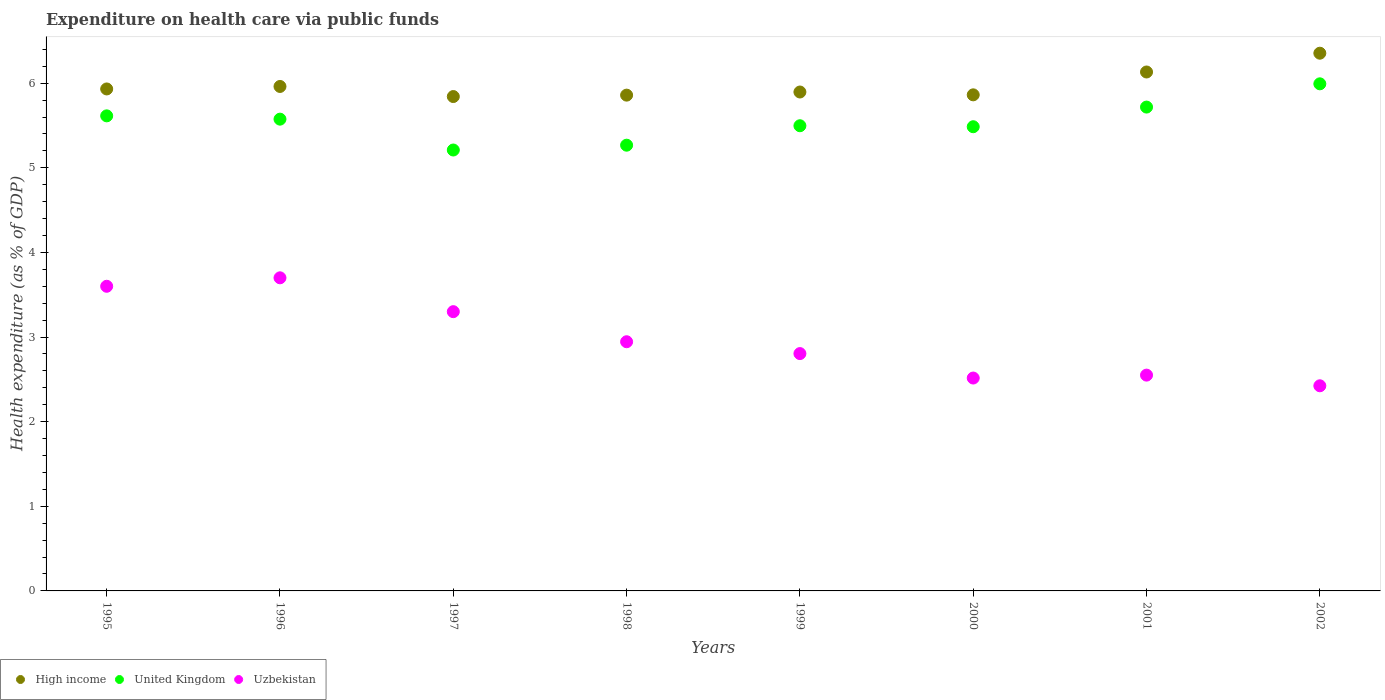Is the number of dotlines equal to the number of legend labels?
Offer a very short reply. Yes. What is the expenditure made on health care in High income in 1999?
Offer a very short reply. 5.9. Across all years, what is the maximum expenditure made on health care in Uzbekistan?
Provide a succinct answer. 3.7. Across all years, what is the minimum expenditure made on health care in Uzbekistan?
Provide a succinct answer. 2.42. What is the total expenditure made on health care in Uzbekistan in the graph?
Your response must be concise. 23.84. What is the difference between the expenditure made on health care in Uzbekistan in 2000 and that in 2001?
Your answer should be compact. -0.03. What is the difference between the expenditure made on health care in United Kingdom in 2002 and the expenditure made on health care in Uzbekistan in 2000?
Ensure brevity in your answer.  3.48. What is the average expenditure made on health care in High income per year?
Keep it short and to the point. 5.98. In the year 2001, what is the difference between the expenditure made on health care in United Kingdom and expenditure made on health care in High income?
Give a very brief answer. -0.41. In how many years, is the expenditure made on health care in United Kingdom greater than 6.2 %?
Offer a very short reply. 0. What is the ratio of the expenditure made on health care in Uzbekistan in 1998 to that in 2002?
Your answer should be compact. 1.21. Is the expenditure made on health care in United Kingdom in 2000 less than that in 2002?
Your answer should be very brief. Yes. What is the difference between the highest and the second highest expenditure made on health care in Uzbekistan?
Give a very brief answer. 0.1. What is the difference between the highest and the lowest expenditure made on health care in Uzbekistan?
Provide a short and direct response. 1.28. Is the sum of the expenditure made on health care in United Kingdom in 1998 and 2001 greater than the maximum expenditure made on health care in High income across all years?
Provide a succinct answer. Yes. What is the difference between two consecutive major ticks on the Y-axis?
Offer a very short reply. 1. Are the values on the major ticks of Y-axis written in scientific E-notation?
Ensure brevity in your answer.  No. Does the graph contain grids?
Offer a very short reply. No. How are the legend labels stacked?
Keep it short and to the point. Horizontal. What is the title of the graph?
Keep it short and to the point. Expenditure on health care via public funds. What is the label or title of the Y-axis?
Offer a terse response. Health expenditure (as % of GDP). What is the Health expenditure (as % of GDP) in High income in 1995?
Your answer should be compact. 5.93. What is the Health expenditure (as % of GDP) of United Kingdom in 1995?
Provide a succinct answer. 5.61. What is the Health expenditure (as % of GDP) of Uzbekistan in 1995?
Give a very brief answer. 3.6. What is the Health expenditure (as % of GDP) of High income in 1996?
Give a very brief answer. 5.96. What is the Health expenditure (as % of GDP) in United Kingdom in 1996?
Your response must be concise. 5.57. What is the Health expenditure (as % of GDP) in Uzbekistan in 1996?
Give a very brief answer. 3.7. What is the Health expenditure (as % of GDP) of High income in 1997?
Offer a very short reply. 5.84. What is the Health expenditure (as % of GDP) of United Kingdom in 1997?
Give a very brief answer. 5.21. What is the Health expenditure (as % of GDP) of Uzbekistan in 1997?
Your response must be concise. 3.3. What is the Health expenditure (as % of GDP) of High income in 1998?
Make the answer very short. 5.86. What is the Health expenditure (as % of GDP) in United Kingdom in 1998?
Ensure brevity in your answer.  5.27. What is the Health expenditure (as % of GDP) in Uzbekistan in 1998?
Your response must be concise. 2.94. What is the Health expenditure (as % of GDP) of High income in 1999?
Your answer should be very brief. 5.9. What is the Health expenditure (as % of GDP) of United Kingdom in 1999?
Your answer should be compact. 5.5. What is the Health expenditure (as % of GDP) in Uzbekistan in 1999?
Offer a very short reply. 2.8. What is the Health expenditure (as % of GDP) of High income in 2000?
Your answer should be compact. 5.86. What is the Health expenditure (as % of GDP) in United Kingdom in 2000?
Offer a very short reply. 5.49. What is the Health expenditure (as % of GDP) of Uzbekistan in 2000?
Keep it short and to the point. 2.52. What is the Health expenditure (as % of GDP) in High income in 2001?
Your response must be concise. 6.13. What is the Health expenditure (as % of GDP) of United Kingdom in 2001?
Give a very brief answer. 5.72. What is the Health expenditure (as % of GDP) of Uzbekistan in 2001?
Make the answer very short. 2.55. What is the Health expenditure (as % of GDP) of High income in 2002?
Offer a terse response. 6.35. What is the Health expenditure (as % of GDP) of United Kingdom in 2002?
Offer a very short reply. 5.99. What is the Health expenditure (as % of GDP) of Uzbekistan in 2002?
Your answer should be compact. 2.42. Across all years, what is the maximum Health expenditure (as % of GDP) of High income?
Offer a very short reply. 6.35. Across all years, what is the maximum Health expenditure (as % of GDP) in United Kingdom?
Your answer should be very brief. 5.99. Across all years, what is the maximum Health expenditure (as % of GDP) in Uzbekistan?
Your answer should be very brief. 3.7. Across all years, what is the minimum Health expenditure (as % of GDP) in High income?
Give a very brief answer. 5.84. Across all years, what is the minimum Health expenditure (as % of GDP) in United Kingdom?
Your answer should be compact. 5.21. Across all years, what is the minimum Health expenditure (as % of GDP) in Uzbekistan?
Ensure brevity in your answer.  2.42. What is the total Health expenditure (as % of GDP) in High income in the graph?
Ensure brevity in your answer.  47.84. What is the total Health expenditure (as % of GDP) of United Kingdom in the graph?
Your answer should be compact. 44.36. What is the total Health expenditure (as % of GDP) of Uzbekistan in the graph?
Your answer should be very brief. 23.84. What is the difference between the Health expenditure (as % of GDP) of High income in 1995 and that in 1996?
Your answer should be very brief. -0.03. What is the difference between the Health expenditure (as % of GDP) of United Kingdom in 1995 and that in 1996?
Give a very brief answer. 0.04. What is the difference between the Health expenditure (as % of GDP) of Uzbekistan in 1995 and that in 1996?
Provide a short and direct response. -0.1. What is the difference between the Health expenditure (as % of GDP) in High income in 1995 and that in 1997?
Ensure brevity in your answer.  0.09. What is the difference between the Health expenditure (as % of GDP) of United Kingdom in 1995 and that in 1997?
Provide a succinct answer. 0.4. What is the difference between the Health expenditure (as % of GDP) of High income in 1995 and that in 1998?
Provide a short and direct response. 0.07. What is the difference between the Health expenditure (as % of GDP) in United Kingdom in 1995 and that in 1998?
Keep it short and to the point. 0.35. What is the difference between the Health expenditure (as % of GDP) in Uzbekistan in 1995 and that in 1998?
Keep it short and to the point. 0.66. What is the difference between the Health expenditure (as % of GDP) in High income in 1995 and that in 1999?
Offer a very short reply. 0.04. What is the difference between the Health expenditure (as % of GDP) of United Kingdom in 1995 and that in 1999?
Your response must be concise. 0.12. What is the difference between the Health expenditure (as % of GDP) of Uzbekistan in 1995 and that in 1999?
Give a very brief answer. 0.8. What is the difference between the Health expenditure (as % of GDP) in High income in 1995 and that in 2000?
Offer a very short reply. 0.07. What is the difference between the Health expenditure (as % of GDP) of United Kingdom in 1995 and that in 2000?
Your answer should be compact. 0.13. What is the difference between the Health expenditure (as % of GDP) of Uzbekistan in 1995 and that in 2000?
Give a very brief answer. 1.08. What is the difference between the Health expenditure (as % of GDP) in High income in 1995 and that in 2001?
Offer a terse response. -0.2. What is the difference between the Health expenditure (as % of GDP) of United Kingdom in 1995 and that in 2001?
Your answer should be very brief. -0.1. What is the difference between the Health expenditure (as % of GDP) in Uzbekistan in 1995 and that in 2001?
Provide a short and direct response. 1.05. What is the difference between the Health expenditure (as % of GDP) in High income in 1995 and that in 2002?
Your response must be concise. -0.42. What is the difference between the Health expenditure (as % of GDP) of United Kingdom in 1995 and that in 2002?
Your response must be concise. -0.38. What is the difference between the Health expenditure (as % of GDP) in Uzbekistan in 1995 and that in 2002?
Your answer should be compact. 1.18. What is the difference between the Health expenditure (as % of GDP) in High income in 1996 and that in 1997?
Your answer should be very brief. 0.12. What is the difference between the Health expenditure (as % of GDP) of United Kingdom in 1996 and that in 1997?
Offer a terse response. 0.36. What is the difference between the Health expenditure (as % of GDP) of Uzbekistan in 1996 and that in 1997?
Keep it short and to the point. 0.4. What is the difference between the Health expenditure (as % of GDP) in High income in 1996 and that in 1998?
Your answer should be very brief. 0.1. What is the difference between the Health expenditure (as % of GDP) in United Kingdom in 1996 and that in 1998?
Your answer should be compact. 0.31. What is the difference between the Health expenditure (as % of GDP) in Uzbekistan in 1996 and that in 1998?
Offer a terse response. 0.76. What is the difference between the Health expenditure (as % of GDP) of High income in 1996 and that in 1999?
Provide a short and direct response. 0.07. What is the difference between the Health expenditure (as % of GDP) in United Kingdom in 1996 and that in 1999?
Your answer should be very brief. 0.08. What is the difference between the Health expenditure (as % of GDP) of Uzbekistan in 1996 and that in 1999?
Make the answer very short. 0.9. What is the difference between the Health expenditure (as % of GDP) in High income in 1996 and that in 2000?
Give a very brief answer. 0.1. What is the difference between the Health expenditure (as % of GDP) in United Kingdom in 1996 and that in 2000?
Your response must be concise. 0.09. What is the difference between the Health expenditure (as % of GDP) in Uzbekistan in 1996 and that in 2000?
Your answer should be compact. 1.18. What is the difference between the Health expenditure (as % of GDP) in High income in 1996 and that in 2001?
Ensure brevity in your answer.  -0.17. What is the difference between the Health expenditure (as % of GDP) of United Kingdom in 1996 and that in 2001?
Your answer should be compact. -0.14. What is the difference between the Health expenditure (as % of GDP) in Uzbekistan in 1996 and that in 2001?
Offer a terse response. 1.15. What is the difference between the Health expenditure (as % of GDP) in High income in 1996 and that in 2002?
Offer a terse response. -0.39. What is the difference between the Health expenditure (as % of GDP) in United Kingdom in 1996 and that in 2002?
Ensure brevity in your answer.  -0.42. What is the difference between the Health expenditure (as % of GDP) of Uzbekistan in 1996 and that in 2002?
Provide a succinct answer. 1.28. What is the difference between the Health expenditure (as % of GDP) of High income in 1997 and that in 1998?
Provide a short and direct response. -0.02. What is the difference between the Health expenditure (as % of GDP) in United Kingdom in 1997 and that in 1998?
Offer a terse response. -0.06. What is the difference between the Health expenditure (as % of GDP) in Uzbekistan in 1997 and that in 1998?
Offer a terse response. 0.36. What is the difference between the Health expenditure (as % of GDP) in High income in 1997 and that in 1999?
Make the answer very short. -0.05. What is the difference between the Health expenditure (as % of GDP) in United Kingdom in 1997 and that in 1999?
Provide a short and direct response. -0.29. What is the difference between the Health expenditure (as % of GDP) in Uzbekistan in 1997 and that in 1999?
Your response must be concise. 0.5. What is the difference between the Health expenditure (as % of GDP) of High income in 1997 and that in 2000?
Provide a short and direct response. -0.02. What is the difference between the Health expenditure (as % of GDP) in United Kingdom in 1997 and that in 2000?
Your answer should be very brief. -0.28. What is the difference between the Health expenditure (as % of GDP) in Uzbekistan in 1997 and that in 2000?
Offer a very short reply. 0.78. What is the difference between the Health expenditure (as % of GDP) in High income in 1997 and that in 2001?
Give a very brief answer. -0.29. What is the difference between the Health expenditure (as % of GDP) of United Kingdom in 1997 and that in 2001?
Keep it short and to the point. -0.51. What is the difference between the Health expenditure (as % of GDP) of Uzbekistan in 1997 and that in 2001?
Provide a short and direct response. 0.75. What is the difference between the Health expenditure (as % of GDP) of High income in 1997 and that in 2002?
Offer a very short reply. -0.51. What is the difference between the Health expenditure (as % of GDP) of United Kingdom in 1997 and that in 2002?
Provide a short and direct response. -0.78. What is the difference between the Health expenditure (as % of GDP) of Uzbekistan in 1997 and that in 2002?
Your answer should be very brief. 0.88. What is the difference between the Health expenditure (as % of GDP) of High income in 1998 and that in 1999?
Give a very brief answer. -0.04. What is the difference between the Health expenditure (as % of GDP) of United Kingdom in 1998 and that in 1999?
Your answer should be very brief. -0.23. What is the difference between the Health expenditure (as % of GDP) in Uzbekistan in 1998 and that in 1999?
Offer a terse response. 0.14. What is the difference between the Health expenditure (as % of GDP) of High income in 1998 and that in 2000?
Give a very brief answer. -0. What is the difference between the Health expenditure (as % of GDP) of United Kingdom in 1998 and that in 2000?
Your answer should be very brief. -0.22. What is the difference between the Health expenditure (as % of GDP) in Uzbekistan in 1998 and that in 2000?
Make the answer very short. 0.43. What is the difference between the Health expenditure (as % of GDP) in High income in 1998 and that in 2001?
Keep it short and to the point. -0.27. What is the difference between the Health expenditure (as % of GDP) of United Kingdom in 1998 and that in 2001?
Your answer should be compact. -0.45. What is the difference between the Health expenditure (as % of GDP) in Uzbekistan in 1998 and that in 2001?
Provide a short and direct response. 0.39. What is the difference between the Health expenditure (as % of GDP) of High income in 1998 and that in 2002?
Your answer should be compact. -0.5. What is the difference between the Health expenditure (as % of GDP) of United Kingdom in 1998 and that in 2002?
Keep it short and to the point. -0.73. What is the difference between the Health expenditure (as % of GDP) of Uzbekistan in 1998 and that in 2002?
Your response must be concise. 0.52. What is the difference between the Health expenditure (as % of GDP) of High income in 1999 and that in 2000?
Provide a succinct answer. 0.03. What is the difference between the Health expenditure (as % of GDP) in United Kingdom in 1999 and that in 2000?
Ensure brevity in your answer.  0.01. What is the difference between the Health expenditure (as % of GDP) of Uzbekistan in 1999 and that in 2000?
Ensure brevity in your answer.  0.29. What is the difference between the Health expenditure (as % of GDP) of High income in 1999 and that in 2001?
Provide a short and direct response. -0.24. What is the difference between the Health expenditure (as % of GDP) of United Kingdom in 1999 and that in 2001?
Give a very brief answer. -0.22. What is the difference between the Health expenditure (as % of GDP) in Uzbekistan in 1999 and that in 2001?
Keep it short and to the point. 0.25. What is the difference between the Health expenditure (as % of GDP) in High income in 1999 and that in 2002?
Your response must be concise. -0.46. What is the difference between the Health expenditure (as % of GDP) in United Kingdom in 1999 and that in 2002?
Ensure brevity in your answer.  -0.5. What is the difference between the Health expenditure (as % of GDP) of Uzbekistan in 1999 and that in 2002?
Your answer should be very brief. 0.38. What is the difference between the Health expenditure (as % of GDP) in High income in 2000 and that in 2001?
Keep it short and to the point. -0.27. What is the difference between the Health expenditure (as % of GDP) of United Kingdom in 2000 and that in 2001?
Provide a succinct answer. -0.23. What is the difference between the Health expenditure (as % of GDP) in Uzbekistan in 2000 and that in 2001?
Offer a terse response. -0.03. What is the difference between the Health expenditure (as % of GDP) of High income in 2000 and that in 2002?
Offer a terse response. -0.49. What is the difference between the Health expenditure (as % of GDP) in United Kingdom in 2000 and that in 2002?
Your answer should be very brief. -0.51. What is the difference between the Health expenditure (as % of GDP) of Uzbekistan in 2000 and that in 2002?
Your response must be concise. 0.09. What is the difference between the Health expenditure (as % of GDP) of High income in 2001 and that in 2002?
Offer a very short reply. -0.22. What is the difference between the Health expenditure (as % of GDP) in United Kingdom in 2001 and that in 2002?
Make the answer very short. -0.27. What is the difference between the Health expenditure (as % of GDP) in Uzbekistan in 2001 and that in 2002?
Provide a short and direct response. 0.13. What is the difference between the Health expenditure (as % of GDP) of High income in 1995 and the Health expenditure (as % of GDP) of United Kingdom in 1996?
Give a very brief answer. 0.36. What is the difference between the Health expenditure (as % of GDP) in High income in 1995 and the Health expenditure (as % of GDP) in Uzbekistan in 1996?
Offer a terse response. 2.23. What is the difference between the Health expenditure (as % of GDP) of United Kingdom in 1995 and the Health expenditure (as % of GDP) of Uzbekistan in 1996?
Offer a terse response. 1.91. What is the difference between the Health expenditure (as % of GDP) of High income in 1995 and the Health expenditure (as % of GDP) of United Kingdom in 1997?
Ensure brevity in your answer.  0.72. What is the difference between the Health expenditure (as % of GDP) in High income in 1995 and the Health expenditure (as % of GDP) in Uzbekistan in 1997?
Your response must be concise. 2.63. What is the difference between the Health expenditure (as % of GDP) in United Kingdom in 1995 and the Health expenditure (as % of GDP) in Uzbekistan in 1997?
Keep it short and to the point. 2.31. What is the difference between the Health expenditure (as % of GDP) in High income in 1995 and the Health expenditure (as % of GDP) in United Kingdom in 1998?
Your answer should be very brief. 0.66. What is the difference between the Health expenditure (as % of GDP) in High income in 1995 and the Health expenditure (as % of GDP) in Uzbekistan in 1998?
Your response must be concise. 2.99. What is the difference between the Health expenditure (as % of GDP) in United Kingdom in 1995 and the Health expenditure (as % of GDP) in Uzbekistan in 1998?
Keep it short and to the point. 2.67. What is the difference between the Health expenditure (as % of GDP) of High income in 1995 and the Health expenditure (as % of GDP) of United Kingdom in 1999?
Make the answer very short. 0.43. What is the difference between the Health expenditure (as % of GDP) of High income in 1995 and the Health expenditure (as % of GDP) of Uzbekistan in 1999?
Give a very brief answer. 3.13. What is the difference between the Health expenditure (as % of GDP) of United Kingdom in 1995 and the Health expenditure (as % of GDP) of Uzbekistan in 1999?
Make the answer very short. 2.81. What is the difference between the Health expenditure (as % of GDP) of High income in 1995 and the Health expenditure (as % of GDP) of United Kingdom in 2000?
Provide a succinct answer. 0.45. What is the difference between the Health expenditure (as % of GDP) of High income in 1995 and the Health expenditure (as % of GDP) of Uzbekistan in 2000?
Your answer should be very brief. 3.42. What is the difference between the Health expenditure (as % of GDP) in United Kingdom in 1995 and the Health expenditure (as % of GDP) in Uzbekistan in 2000?
Give a very brief answer. 3.1. What is the difference between the Health expenditure (as % of GDP) in High income in 1995 and the Health expenditure (as % of GDP) in United Kingdom in 2001?
Give a very brief answer. 0.21. What is the difference between the Health expenditure (as % of GDP) in High income in 1995 and the Health expenditure (as % of GDP) in Uzbekistan in 2001?
Keep it short and to the point. 3.38. What is the difference between the Health expenditure (as % of GDP) of United Kingdom in 1995 and the Health expenditure (as % of GDP) of Uzbekistan in 2001?
Keep it short and to the point. 3.06. What is the difference between the Health expenditure (as % of GDP) of High income in 1995 and the Health expenditure (as % of GDP) of United Kingdom in 2002?
Give a very brief answer. -0.06. What is the difference between the Health expenditure (as % of GDP) in High income in 1995 and the Health expenditure (as % of GDP) in Uzbekistan in 2002?
Offer a terse response. 3.51. What is the difference between the Health expenditure (as % of GDP) in United Kingdom in 1995 and the Health expenditure (as % of GDP) in Uzbekistan in 2002?
Provide a short and direct response. 3.19. What is the difference between the Health expenditure (as % of GDP) in High income in 1996 and the Health expenditure (as % of GDP) in United Kingdom in 1997?
Your response must be concise. 0.75. What is the difference between the Health expenditure (as % of GDP) in High income in 1996 and the Health expenditure (as % of GDP) in Uzbekistan in 1997?
Your answer should be very brief. 2.66. What is the difference between the Health expenditure (as % of GDP) of United Kingdom in 1996 and the Health expenditure (as % of GDP) of Uzbekistan in 1997?
Your answer should be very brief. 2.27. What is the difference between the Health expenditure (as % of GDP) of High income in 1996 and the Health expenditure (as % of GDP) of United Kingdom in 1998?
Ensure brevity in your answer.  0.69. What is the difference between the Health expenditure (as % of GDP) in High income in 1996 and the Health expenditure (as % of GDP) in Uzbekistan in 1998?
Your answer should be very brief. 3.02. What is the difference between the Health expenditure (as % of GDP) of United Kingdom in 1996 and the Health expenditure (as % of GDP) of Uzbekistan in 1998?
Provide a succinct answer. 2.63. What is the difference between the Health expenditure (as % of GDP) of High income in 1996 and the Health expenditure (as % of GDP) of United Kingdom in 1999?
Provide a succinct answer. 0.46. What is the difference between the Health expenditure (as % of GDP) of High income in 1996 and the Health expenditure (as % of GDP) of Uzbekistan in 1999?
Offer a terse response. 3.16. What is the difference between the Health expenditure (as % of GDP) in United Kingdom in 1996 and the Health expenditure (as % of GDP) in Uzbekistan in 1999?
Make the answer very short. 2.77. What is the difference between the Health expenditure (as % of GDP) in High income in 1996 and the Health expenditure (as % of GDP) in United Kingdom in 2000?
Your answer should be very brief. 0.48. What is the difference between the Health expenditure (as % of GDP) in High income in 1996 and the Health expenditure (as % of GDP) in Uzbekistan in 2000?
Ensure brevity in your answer.  3.45. What is the difference between the Health expenditure (as % of GDP) of United Kingdom in 1996 and the Health expenditure (as % of GDP) of Uzbekistan in 2000?
Offer a terse response. 3.06. What is the difference between the Health expenditure (as % of GDP) in High income in 1996 and the Health expenditure (as % of GDP) in United Kingdom in 2001?
Your answer should be very brief. 0.24. What is the difference between the Health expenditure (as % of GDP) in High income in 1996 and the Health expenditure (as % of GDP) in Uzbekistan in 2001?
Offer a very short reply. 3.41. What is the difference between the Health expenditure (as % of GDP) in United Kingdom in 1996 and the Health expenditure (as % of GDP) in Uzbekistan in 2001?
Provide a short and direct response. 3.02. What is the difference between the Health expenditure (as % of GDP) in High income in 1996 and the Health expenditure (as % of GDP) in United Kingdom in 2002?
Your answer should be compact. -0.03. What is the difference between the Health expenditure (as % of GDP) of High income in 1996 and the Health expenditure (as % of GDP) of Uzbekistan in 2002?
Provide a short and direct response. 3.54. What is the difference between the Health expenditure (as % of GDP) in United Kingdom in 1996 and the Health expenditure (as % of GDP) in Uzbekistan in 2002?
Your answer should be very brief. 3.15. What is the difference between the Health expenditure (as % of GDP) of High income in 1997 and the Health expenditure (as % of GDP) of United Kingdom in 1998?
Provide a succinct answer. 0.57. What is the difference between the Health expenditure (as % of GDP) in High income in 1997 and the Health expenditure (as % of GDP) in Uzbekistan in 1998?
Keep it short and to the point. 2.9. What is the difference between the Health expenditure (as % of GDP) of United Kingdom in 1997 and the Health expenditure (as % of GDP) of Uzbekistan in 1998?
Offer a terse response. 2.27. What is the difference between the Health expenditure (as % of GDP) of High income in 1997 and the Health expenditure (as % of GDP) of United Kingdom in 1999?
Your answer should be very brief. 0.34. What is the difference between the Health expenditure (as % of GDP) in High income in 1997 and the Health expenditure (as % of GDP) in Uzbekistan in 1999?
Offer a very short reply. 3.04. What is the difference between the Health expenditure (as % of GDP) of United Kingdom in 1997 and the Health expenditure (as % of GDP) of Uzbekistan in 1999?
Provide a succinct answer. 2.41. What is the difference between the Health expenditure (as % of GDP) in High income in 1997 and the Health expenditure (as % of GDP) in United Kingdom in 2000?
Your answer should be compact. 0.36. What is the difference between the Health expenditure (as % of GDP) of High income in 1997 and the Health expenditure (as % of GDP) of Uzbekistan in 2000?
Offer a terse response. 3.33. What is the difference between the Health expenditure (as % of GDP) in United Kingdom in 1997 and the Health expenditure (as % of GDP) in Uzbekistan in 2000?
Provide a succinct answer. 2.69. What is the difference between the Health expenditure (as % of GDP) in High income in 1997 and the Health expenditure (as % of GDP) in United Kingdom in 2001?
Provide a short and direct response. 0.12. What is the difference between the Health expenditure (as % of GDP) of High income in 1997 and the Health expenditure (as % of GDP) of Uzbekistan in 2001?
Keep it short and to the point. 3.29. What is the difference between the Health expenditure (as % of GDP) of United Kingdom in 1997 and the Health expenditure (as % of GDP) of Uzbekistan in 2001?
Provide a succinct answer. 2.66. What is the difference between the Health expenditure (as % of GDP) in High income in 1997 and the Health expenditure (as % of GDP) in United Kingdom in 2002?
Provide a short and direct response. -0.15. What is the difference between the Health expenditure (as % of GDP) of High income in 1997 and the Health expenditure (as % of GDP) of Uzbekistan in 2002?
Make the answer very short. 3.42. What is the difference between the Health expenditure (as % of GDP) of United Kingdom in 1997 and the Health expenditure (as % of GDP) of Uzbekistan in 2002?
Provide a succinct answer. 2.79. What is the difference between the Health expenditure (as % of GDP) in High income in 1998 and the Health expenditure (as % of GDP) in United Kingdom in 1999?
Provide a short and direct response. 0.36. What is the difference between the Health expenditure (as % of GDP) of High income in 1998 and the Health expenditure (as % of GDP) of Uzbekistan in 1999?
Your response must be concise. 3.05. What is the difference between the Health expenditure (as % of GDP) of United Kingdom in 1998 and the Health expenditure (as % of GDP) of Uzbekistan in 1999?
Offer a very short reply. 2.46. What is the difference between the Health expenditure (as % of GDP) in High income in 1998 and the Health expenditure (as % of GDP) in United Kingdom in 2000?
Provide a succinct answer. 0.37. What is the difference between the Health expenditure (as % of GDP) of High income in 1998 and the Health expenditure (as % of GDP) of Uzbekistan in 2000?
Provide a succinct answer. 3.34. What is the difference between the Health expenditure (as % of GDP) in United Kingdom in 1998 and the Health expenditure (as % of GDP) in Uzbekistan in 2000?
Give a very brief answer. 2.75. What is the difference between the Health expenditure (as % of GDP) in High income in 1998 and the Health expenditure (as % of GDP) in United Kingdom in 2001?
Your answer should be compact. 0.14. What is the difference between the Health expenditure (as % of GDP) of High income in 1998 and the Health expenditure (as % of GDP) of Uzbekistan in 2001?
Your response must be concise. 3.31. What is the difference between the Health expenditure (as % of GDP) of United Kingdom in 1998 and the Health expenditure (as % of GDP) of Uzbekistan in 2001?
Provide a succinct answer. 2.72. What is the difference between the Health expenditure (as % of GDP) of High income in 1998 and the Health expenditure (as % of GDP) of United Kingdom in 2002?
Your response must be concise. -0.13. What is the difference between the Health expenditure (as % of GDP) in High income in 1998 and the Health expenditure (as % of GDP) in Uzbekistan in 2002?
Offer a very short reply. 3.43. What is the difference between the Health expenditure (as % of GDP) in United Kingdom in 1998 and the Health expenditure (as % of GDP) in Uzbekistan in 2002?
Make the answer very short. 2.84. What is the difference between the Health expenditure (as % of GDP) of High income in 1999 and the Health expenditure (as % of GDP) of United Kingdom in 2000?
Offer a terse response. 0.41. What is the difference between the Health expenditure (as % of GDP) in High income in 1999 and the Health expenditure (as % of GDP) in Uzbekistan in 2000?
Make the answer very short. 3.38. What is the difference between the Health expenditure (as % of GDP) in United Kingdom in 1999 and the Health expenditure (as % of GDP) in Uzbekistan in 2000?
Your answer should be compact. 2.98. What is the difference between the Health expenditure (as % of GDP) of High income in 1999 and the Health expenditure (as % of GDP) of United Kingdom in 2001?
Your response must be concise. 0.18. What is the difference between the Health expenditure (as % of GDP) in High income in 1999 and the Health expenditure (as % of GDP) in Uzbekistan in 2001?
Provide a succinct answer. 3.35. What is the difference between the Health expenditure (as % of GDP) in United Kingdom in 1999 and the Health expenditure (as % of GDP) in Uzbekistan in 2001?
Your response must be concise. 2.95. What is the difference between the Health expenditure (as % of GDP) of High income in 1999 and the Health expenditure (as % of GDP) of United Kingdom in 2002?
Make the answer very short. -0.1. What is the difference between the Health expenditure (as % of GDP) of High income in 1999 and the Health expenditure (as % of GDP) of Uzbekistan in 2002?
Your response must be concise. 3.47. What is the difference between the Health expenditure (as % of GDP) in United Kingdom in 1999 and the Health expenditure (as % of GDP) in Uzbekistan in 2002?
Give a very brief answer. 3.07. What is the difference between the Health expenditure (as % of GDP) in High income in 2000 and the Health expenditure (as % of GDP) in United Kingdom in 2001?
Make the answer very short. 0.14. What is the difference between the Health expenditure (as % of GDP) in High income in 2000 and the Health expenditure (as % of GDP) in Uzbekistan in 2001?
Keep it short and to the point. 3.31. What is the difference between the Health expenditure (as % of GDP) of United Kingdom in 2000 and the Health expenditure (as % of GDP) of Uzbekistan in 2001?
Offer a very short reply. 2.94. What is the difference between the Health expenditure (as % of GDP) of High income in 2000 and the Health expenditure (as % of GDP) of United Kingdom in 2002?
Provide a succinct answer. -0.13. What is the difference between the Health expenditure (as % of GDP) of High income in 2000 and the Health expenditure (as % of GDP) of Uzbekistan in 2002?
Provide a succinct answer. 3.44. What is the difference between the Health expenditure (as % of GDP) in United Kingdom in 2000 and the Health expenditure (as % of GDP) in Uzbekistan in 2002?
Offer a very short reply. 3.06. What is the difference between the Health expenditure (as % of GDP) of High income in 2001 and the Health expenditure (as % of GDP) of United Kingdom in 2002?
Provide a short and direct response. 0.14. What is the difference between the Health expenditure (as % of GDP) of High income in 2001 and the Health expenditure (as % of GDP) of Uzbekistan in 2002?
Your response must be concise. 3.71. What is the difference between the Health expenditure (as % of GDP) in United Kingdom in 2001 and the Health expenditure (as % of GDP) in Uzbekistan in 2002?
Provide a succinct answer. 3.29. What is the average Health expenditure (as % of GDP) in High income per year?
Your answer should be very brief. 5.98. What is the average Health expenditure (as % of GDP) of United Kingdom per year?
Provide a short and direct response. 5.54. What is the average Health expenditure (as % of GDP) of Uzbekistan per year?
Give a very brief answer. 2.98. In the year 1995, what is the difference between the Health expenditure (as % of GDP) in High income and Health expenditure (as % of GDP) in United Kingdom?
Provide a short and direct response. 0.32. In the year 1995, what is the difference between the Health expenditure (as % of GDP) of High income and Health expenditure (as % of GDP) of Uzbekistan?
Give a very brief answer. 2.33. In the year 1995, what is the difference between the Health expenditure (as % of GDP) of United Kingdom and Health expenditure (as % of GDP) of Uzbekistan?
Keep it short and to the point. 2.01. In the year 1996, what is the difference between the Health expenditure (as % of GDP) of High income and Health expenditure (as % of GDP) of United Kingdom?
Your answer should be very brief. 0.39. In the year 1996, what is the difference between the Health expenditure (as % of GDP) in High income and Health expenditure (as % of GDP) in Uzbekistan?
Offer a terse response. 2.26. In the year 1996, what is the difference between the Health expenditure (as % of GDP) in United Kingdom and Health expenditure (as % of GDP) in Uzbekistan?
Make the answer very short. 1.87. In the year 1997, what is the difference between the Health expenditure (as % of GDP) of High income and Health expenditure (as % of GDP) of United Kingdom?
Your response must be concise. 0.63. In the year 1997, what is the difference between the Health expenditure (as % of GDP) of High income and Health expenditure (as % of GDP) of Uzbekistan?
Your answer should be very brief. 2.54. In the year 1997, what is the difference between the Health expenditure (as % of GDP) in United Kingdom and Health expenditure (as % of GDP) in Uzbekistan?
Keep it short and to the point. 1.91. In the year 1998, what is the difference between the Health expenditure (as % of GDP) in High income and Health expenditure (as % of GDP) in United Kingdom?
Provide a short and direct response. 0.59. In the year 1998, what is the difference between the Health expenditure (as % of GDP) of High income and Health expenditure (as % of GDP) of Uzbekistan?
Offer a very short reply. 2.91. In the year 1998, what is the difference between the Health expenditure (as % of GDP) of United Kingdom and Health expenditure (as % of GDP) of Uzbekistan?
Provide a short and direct response. 2.32. In the year 1999, what is the difference between the Health expenditure (as % of GDP) in High income and Health expenditure (as % of GDP) in United Kingdom?
Offer a terse response. 0.4. In the year 1999, what is the difference between the Health expenditure (as % of GDP) of High income and Health expenditure (as % of GDP) of Uzbekistan?
Your answer should be compact. 3.09. In the year 1999, what is the difference between the Health expenditure (as % of GDP) of United Kingdom and Health expenditure (as % of GDP) of Uzbekistan?
Give a very brief answer. 2.69. In the year 2000, what is the difference between the Health expenditure (as % of GDP) in High income and Health expenditure (as % of GDP) in United Kingdom?
Keep it short and to the point. 0.38. In the year 2000, what is the difference between the Health expenditure (as % of GDP) of High income and Health expenditure (as % of GDP) of Uzbekistan?
Your answer should be compact. 3.35. In the year 2000, what is the difference between the Health expenditure (as % of GDP) in United Kingdom and Health expenditure (as % of GDP) in Uzbekistan?
Provide a succinct answer. 2.97. In the year 2001, what is the difference between the Health expenditure (as % of GDP) of High income and Health expenditure (as % of GDP) of United Kingdom?
Offer a terse response. 0.41. In the year 2001, what is the difference between the Health expenditure (as % of GDP) of High income and Health expenditure (as % of GDP) of Uzbekistan?
Your answer should be compact. 3.58. In the year 2001, what is the difference between the Health expenditure (as % of GDP) in United Kingdom and Health expenditure (as % of GDP) in Uzbekistan?
Keep it short and to the point. 3.17. In the year 2002, what is the difference between the Health expenditure (as % of GDP) of High income and Health expenditure (as % of GDP) of United Kingdom?
Offer a very short reply. 0.36. In the year 2002, what is the difference between the Health expenditure (as % of GDP) of High income and Health expenditure (as % of GDP) of Uzbekistan?
Make the answer very short. 3.93. In the year 2002, what is the difference between the Health expenditure (as % of GDP) of United Kingdom and Health expenditure (as % of GDP) of Uzbekistan?
Provide a succinct answer. 3.57. What is the ratio of the Health expenditure (as % of GDP) of United Kingdom in 1995 to that in 1996?
Your answer should be very brief. 1.01. What is the ratio of the Health expenditure (as % of GDP) in High income in 1995 to that in 1997?
Provide a short and direct response. 1.02. What is the ratio of the Health expenditure (as % of GDP) of United Kingdom in 1995 to that in 1997?
Your answer should be very brief. 1.08. What is the ratio of the Health expenditure (as % of GDP) in High income in 1995 to that in 1998?
Offer a terse response. 1.01. What is the ratio of the Health expenditure (as % of GDP) in United Kingdom in 1995 to that in 1998?
Provide a succinct answer. 1.07. What is the ratio of the Health expenditure (as % of GDP) of Uzbekistan in 1995 to that in 1998?
Give a very brief answer. 1.22. What is the ratio of the Health expenditure (as % of GDP) of High income in 1995 to that in 1999?
Offer a terse response. 1.01. What is the ratio of the Health expenditure (as % of GDP) of United Kingdom in 1995 to that in 1999?
Your answer should be very brief. 1.02. What is the ratio of the Health expenditure (as % of GDP) in Uzbekistan in 1995 to that in 1999?
Offer a terse response. 1.28. What is the ratio of the Health expenditure (as % of GDP) of High income in 1995 to that in 2000?
Your response must be concise. 1.01. What is the ratio of the Health expenditure (as % of GDP) in United Kingdom in 1995 to that in 2000?
Keep it short and to the point. 1.02. What is the ratio of the Health expenditure (as % of GDP) of Uzbekistan in 1995 to that in 2000?
Keep it short and to the point. 1.43. What is the ratio of the Health expenditure (as % of GDP) of High income in 1995 to that in 2001?
Ensure brevity in your answer.  0.97. What is the ratio of the Health expenditure (as % of GDP) in United Kingdom in 1995 to that in 2001?
Offer a very short reply. 0.98. What is the ratio of the Health expenditure (as % of GDP) in Uzbekistan in 1995 to that in 2001?
Keep it short and to the point. 1.41. What is the ratio of the Health expenditure (as % of GDP) in High income in 1995 to that in 2002?
Ensure brevity in your answer.  0.93. What is the ratio of the Health expenditure (as % of GDP) of United Kingdom in 1995 to that in 2002?
Keep it short and to the point. 0.94. What is the ratio of the Health expenditure (as % of GDP) in Uzbekistan in 1995 to that in 2002?
Your answer should be very brief. 1.49. What is the ratio of the Health expenditure (as % of GDP) in High income in 1996 to that in 1997?
Your answer should be compact. 1.02. What is the ratio of the Health expenditure (as % of GDP) of United Kingdom in 1996 to that in 1997?
Provide a short and direct response. 1.07. What is the ratio of the Health expenditure (as % of GDP) in Uzbekistan in 1996 to that in 1997?
Offer a terse response. 1.12. What is the ratio of the Health expenditure (as % of GDP) of High income in 1996 to that in 1998?
Give a very brief answer. 1.02. What is the ratio of the Health expenditure (as % of GDP) in United Kingdom in 1996 to that in 1998?
Ensure brevity in your answer.  1.06. What is the ratio of the Health expenditure (as % of GDP) of Uzbekistan in 1996 to that in 1998?
Keep it short and to the point. 1.26. What is the ratio of the Health expenditure (as % of GDP) in High income in 1996 to that in 1999?
Give a very brief answer. 1.01. What is the ratio of the Health expenditure (as % of GDP) of United Kingdom in 1996 to that in 1999?
Make the answer very short. 1.01. What is the ratio of the Health expenditure (as % of GDP) of Uzbekistan in 1996 to that in 1999?
Your answer should be very brief. 1.32. What is the ratio of the Health expenditure (as % of GDP) in High income in 1996 to that in 2000?
Give a very brief answer. 1.02. What is the ratio of the Health expenditure (as % of GDP) of United Kingdom in 1996 to that in 2000?
Offer a very short reply. 1.02. What is the ratio of the Health expenditure (as % of GDP) of Uzbekistan in 1996 to that in 2000?
Your answer should be compact. 1.47. What is the ratio of the Health expenditure (as % of GDP) of High income in 1996 to that in 2001?
Ensure brevity in your answer.  0.97. What is the ratio of the Health expenditure (as % of GDP) of United Kingdom in 1996 to that in 2001?
Ensure brevity in your answer.  0.97. What is the ratio of the Health expenditure (as % of GDP) in Uzbekistan in 1996 to that in 2001?
Provide a short and direct response. 1.45. What is the ratio of the Health expenditure (as % of GDP) of High income in 1996 to that in 2002?
Offer a very short reply. 0.94. What is the ratio of the Health expenditure (as % of GDP) in United Kingdom in 1996 to that in 2002?
Keep it short and to the point. 0.93. What is the ratio of the Health expenditure (as % of GDP) in Uzbekistan in 1996 to that in 2002?
Your response must be concise. 1.53. What is the ratio of the Health expenditure (as % of GDP) of High income in 1997 to that in 1998?
Make the answer very short. 1. What is the ratio of the Health expenditure (as % of GDP) of United Kingdom in 1997 to that in 1998?
Ensure brevity in your answer.  0.99. What is the ratio of the Health expenditure (as % of GDP) of Uzbekistan in 1997 to that in 1998?
Keep it short and to the point. 1.12. What is the ratio of the Health expenditure (as % of GDP) of High income in 1997 to that in 1999?
Your response must be concise. 0.99. What is the ratio of the Health expenditure (as % of GDP) in United Kingdom in 1997 to that in 1999?
Give a very brief answer. 0.95. What is the ratio of the Health expenditure (as % of GDP) of Uzbekistan in 1997 to that in 1999?
Keep it short and to the point. 1.18. What is the ratio of the Health expenditure (as % of GDP) in High income in 1997 to that in 2000?
Offer a terse response. 1. What is the ratio of the Health expenditure (as % of GDP) of United Kingdom in 1997 to that in 2000?
Your answer should be very brief. 0.95. What is the ratio of the Health expenditure (as % of GDP) of Uzbekistan in 1997 to that in 2000?
Your response must be concise. 1.31. What is the ratio of the Health expenditure (as % of GDP) of High income in 1997 to that in 2001?
Your answer should be compact. 0.95. What is the ratio of the Health expenditure (as % of GDP) in United Kingdom in 1997 to that in 2001?
Keep it short and to the point. 0.91. What is the ratio of the Health expenditure (as % of GDP) in Uzbekistan in 1997 to that in 2001?
Provide a succinct answer. 1.29. What is the ratio of the Health expenditure (as % of GDP) in High income in 1997 to that in 2002?
Offer a very short reply. 0.92. What is the ratio of the Health expenditure (as % of GDP) of United Kingdom in 1997 to that in 2002?
Offer a very short reply. 0.87. What is the ratio of the Health expenditure (as % of GDP) in Uzbekistan in 1997 to that in 2002?
Provide a succinct answer. 1.36. What is the ratio of the Health expenditure (as % of GDP) in United Kingdom in 1998 to that in 1999?
Your response must be concise. 0.96. What is the ratio of the Health expenditure (as % of GDP) in Uzbekistan in 1998 to that in 1999?
Provide a succinct answer. 1.05. What is the ratio of the Health expenditure (as % of GDP) of United Kingdom in 1998 to that in 2000?
Your answer should be compact. 0.96. What is the ratio of the Health expenditure (as % of GDP) of Uzbekistan in 1998 to that in 2000?
Provide a short and direct response. 1.17. What is the ratio of the Health expenditure (as % of GDP) of High income in 1998 to that in 2001?
Your answer should be compact. 0.96. What is the ratio of the Health expenditure (as % of GDP) of United Kingdom in 1998 to that in 2001?
Your answer should be compact. 0.92. What is the ratio of the Health expenditure (as % of GDP) in Uzbekistan in 1998 to that in 2001?
Offer a very short reply. 1.15. What is the ratio of the Health expenditure (as % of GDP) of High income in 1998 to that in 2002?
Your answer should be compact. 0.92. What is the ratio of the Health expenditure (as % of GDP) in United Kingdom in 1998 to that in 2002?
Provide a succinct answer. 0.88. What is the ratio of the Health expenditure (as % of GDP) of Uzbekistan in 1998 to that in 2002?
Your answer should be compact. 1.21. What is the ratio of the Health expenditure (as % of GDP) in United Kingdom in 1999 to that in 2000?
Your answer should be compact. 1. What is the ratio of the Health expenditure (as % of GDP) of Uzbekistan in 1999 to that in 2000?
Keep it short and to the point. 1.11. What is the ratio of the Health expenditure (as % of GDP) in High income in 1999 to that in 2001?
Provide a succinct answer. 0.96. What is the ratio of the Health expenditure (as % of GDP) of United Kingdom in 1999 to that in 2001?
Your response must be concise. 0.96. What is the ratio of the Health expenditure (as % of GDP) in Uzbekistan in 1999 to that in 2001?
Provide a short and direct response. 1.1. What is the ratio of the Health expenditure (as % of GDP) in High income in 1999 to that in 2002?
Ensure brevity in your answer.  0.93. What is the ratio of the Health expenditure (as % of GDP) of United Kingdom in 1999 to that in 2002?
Keep it short and to the point. 0.92. What is the ratio of the Health expenditure (as % of GDP) of Uzbekistan in 1999 to that in 2002?
Offer a very short reply. 1.16. What is the ratio of the Health expenditure (as % of GDP) of High income in 2000 to that in 2001?
Ensure brevity in your answer.  0.96. What is the ratio of the Health expenditure (as % of GDP) of United Kingdom in 2000 to that in 2001?
Your answer should be very brief. 0.96. What is the ratio of the Health expenditure (as % of GDP) of Uzbekistan in 2000 to that in 2001?
Provide a short and direct response. 0.99. What is the ratio of the Health expenditure (as % of GDP) of High income in 2000 to that in 2002?
Offer a terse response. 0.92. What is the ratio of the Health expenditure (as % of GDP) in United Kingdom in 2000 to that in 2002?
Provide a succinct answer. 0.92. What is the ratio of the Health expenditure (as % of GDP) in Uzbekistan in 2000 to that in 2002?
Your answer should be very brief. 1.04. What is the ratio of the Health expenditure (as % of GDP) in High income in 2001 to that in 2002?
Your answer should be compact. 0.97. What is the ratio of the Health expenditure (as % of GDP) in United Kingdom in 2001 to that in 2002?
Ensure brevity in your answer.  0.95. What is the ratio of the Health expenditure (as % of GDP) in Uzbekistan in 2001 to that in 2002?
Your answer should be compact. 1.05. What is the difference between the highest and the second highest Health expenditure (as % of GDP) in High income?
Keep it short and to the point. 0.22. What is the difference between the highest and the second highest Health expenditure (as % of GDP) in United Kingdom?
Keep it short and to the point. 0.27. What is the difference between the highest and the second highest Health expenditure (as % of GDP) of Uzbekistan?
Give a very brief answer. 0.1. What is the difference between the highest and the lowest Health expenditure (as % of GDP) of High income?
Your answer should be very brief. 0.51. What is the difference between the highest and the lowest Health expenditure (as % of GDP) in United Kingdom?
Provide a succinct answer. 0.78. What is the difference between the highest and the lowest Health expenditure (as % of GDP) in Uzbekistan?
Offer a very short reply. 1.28. 